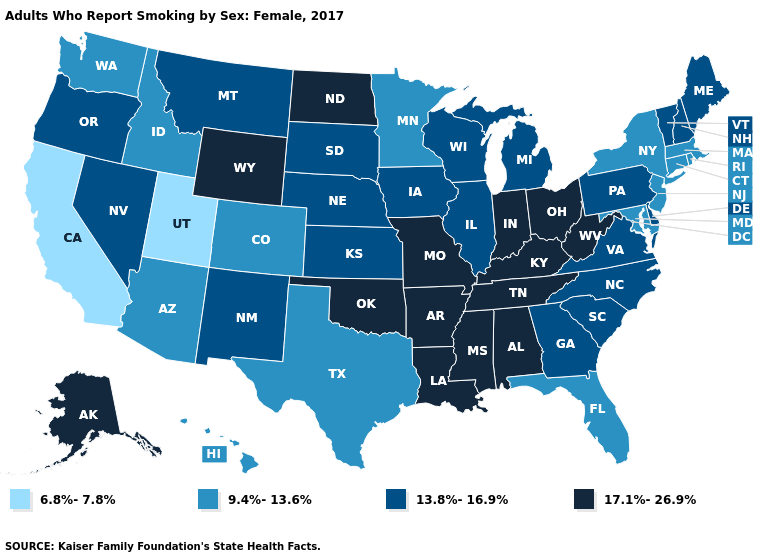What is the value of Florida?
Keep it brief. 9.4%-13.6%. Which states have the highest value in the USA?
Short answer required. Alabama, Alaska, Arkansas, Indiana, Kentucky, Louisiana, Mississippi, Missouri, North Dakota, Ohio, Oklahoma, Tennessee, West Virginia, Wyoming. Which states have the lowest value in the South?
Keep it brief. Florida, Maryland, Texas. Name the states that have a value in the range 6.8%-7.8%?
Give a very brief answer. California, Utah. What is the value of Rhode Island?
Short answer required. 9.4%-13.6%. What is the value of Illinois?
Quick response, please. 13.8%-16.9%. Name the states that have a value in the range 17.1%-26.9%?
Quick response, please. Alabama, Alaska, Arkansas, Indiana, Kentucky, Louisiana, Mississippi, Missouri, North Dakota, Ohio, Oklahoma, Tennessee, West Virginia, Wyoming. Name the states that have a value in the range 9.4%-13.6%?
Be succinct. Arizona, Colorado, Connecticut, Florida, Hawaii, Idaho, Maryland, Massachusetts, Minnesota, New Jersey, New York, Rhode Island, Texas, Washington. What is the value of Maine?
Keep it brief. 13.8%-16.9%. Does Alaska have the lowest value in the West?
Write a very short answer. No. Name the states that have a value in the range 6.8%-7.8%?
Answer briefly. California, Utah. Does Connecticut have the highest value in the Northeast?
Write a very short answer. No. Does Hawaii have the lowest value in the USA?
Quick response, please. No. What is the lowest value in states that border South Carolina?
Short answer required. 13.8%-16.9%. Is the legend a continuous bar?
Write a very short answer. No. 